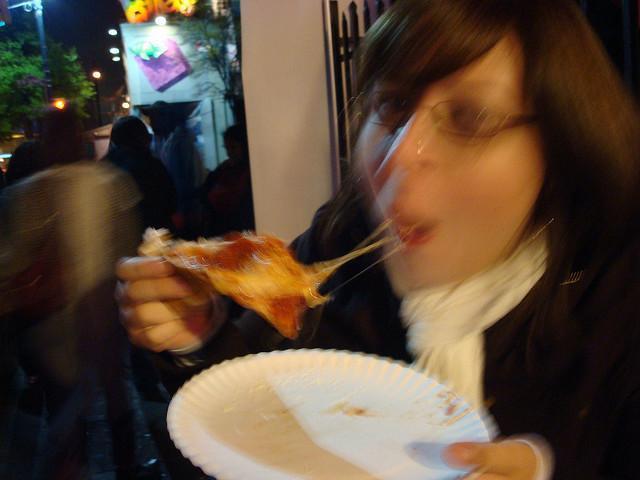How many people are there?
Give a very brief answer. 5. 